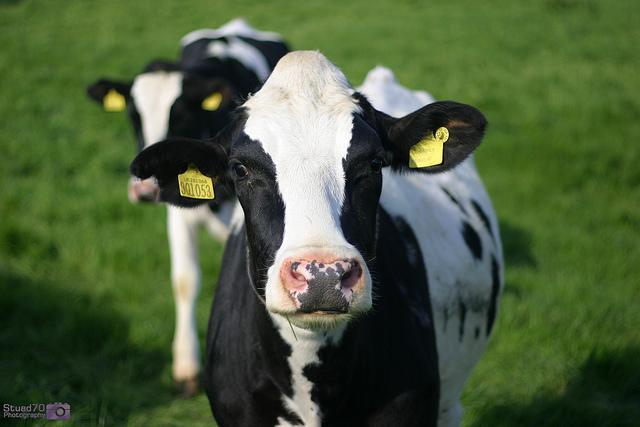Are those tags natural?
Concise answer only. No. What number is seen?
Be succinct. 301053. What is this?
Concise answer only. Cow. Has the cow been eating grass?
Give a very brief answer. Yes. Are the cows standing or sitting?
Short answer required. Standing. 